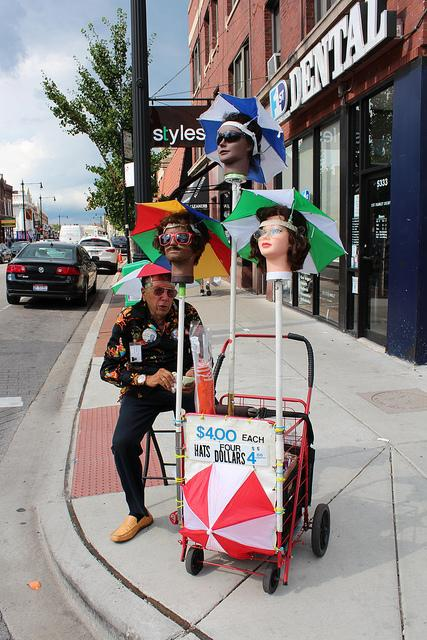What can the clinic on the right help you with?

Choices:
A) eyes
B) feet
C) teeth
D) back teeth 